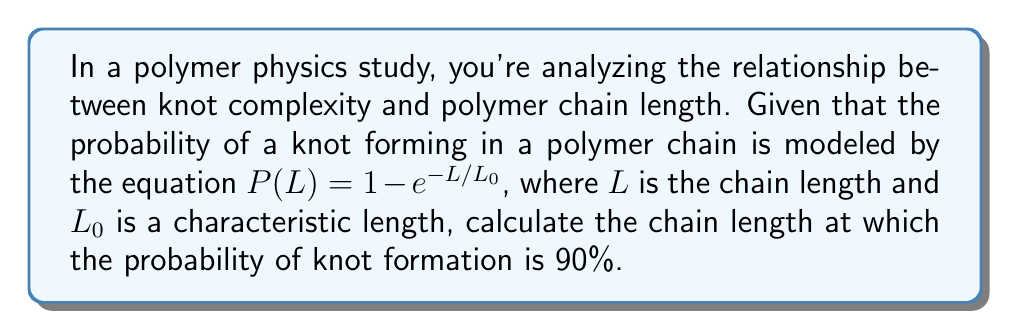Could you help me with this problem? To solve this problem, we'll follow these steps:

1) The equation given is $P(L) = 1 - e^{-L/L_0}$

2) We want to find $L$ when $P(L) = 0.90$ (90%)

3) Let's substitute these values into the equation:

   $0.90 = 1 - e^{-L/L_0}$

4) Subtract both sides from 1:

   $0.10 = e^{-L/L_0}$

5) Take the natural logarithm of both sides:

   $\ln(0.10) = -L/L_0$

6) Multiply both sides by $-L_0$:

   $-L_0 \ln(0.10) = L$

7) Calculate the value (note that $\ln(0.10) \approx -2.30259$):

   $L = -L_0 \cdot (-2.30259) = 2.30259L_0$

Therefore, the chain length at which the probability of knot formation is 90% is approximately $2.30259L_0$.
Answer: $2.30259L_0$ 